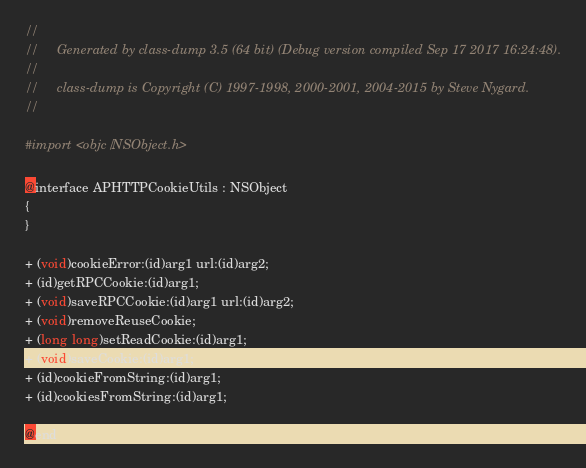Convert code to text. <code><loc_0><loc_0><loc_500><loc_500><_C_>//
//     Generated by class-dump 3.5 (64 bit) (Debug version compiled Sep 17 2017 16:24:48).
//
//     class-dump is Copyright (C) 1997-1998, 2000-2001, 2004-2015 by Steve Nygard.
//

#import <objc/NSObject.h>

@interface APHTTPCookieUtils : NSObject
{
}

+ (void)cookieError:(id)arg1 url:(id)arg2;
+ (id)getRPCCookie:(id)arg1;
+ (void)saveRPCCookie:(id)arg1 url:(id)arg2;
+ (void)removeReuseCookie;
+ (long long)setReadCookie:(id)arg1;
+ (void)saveCookie:(id)arg1;
+ (id)cookieFromString:(id)arg1;
+ (id)cookiesFromString:(id)arg1;

@end

</code> 